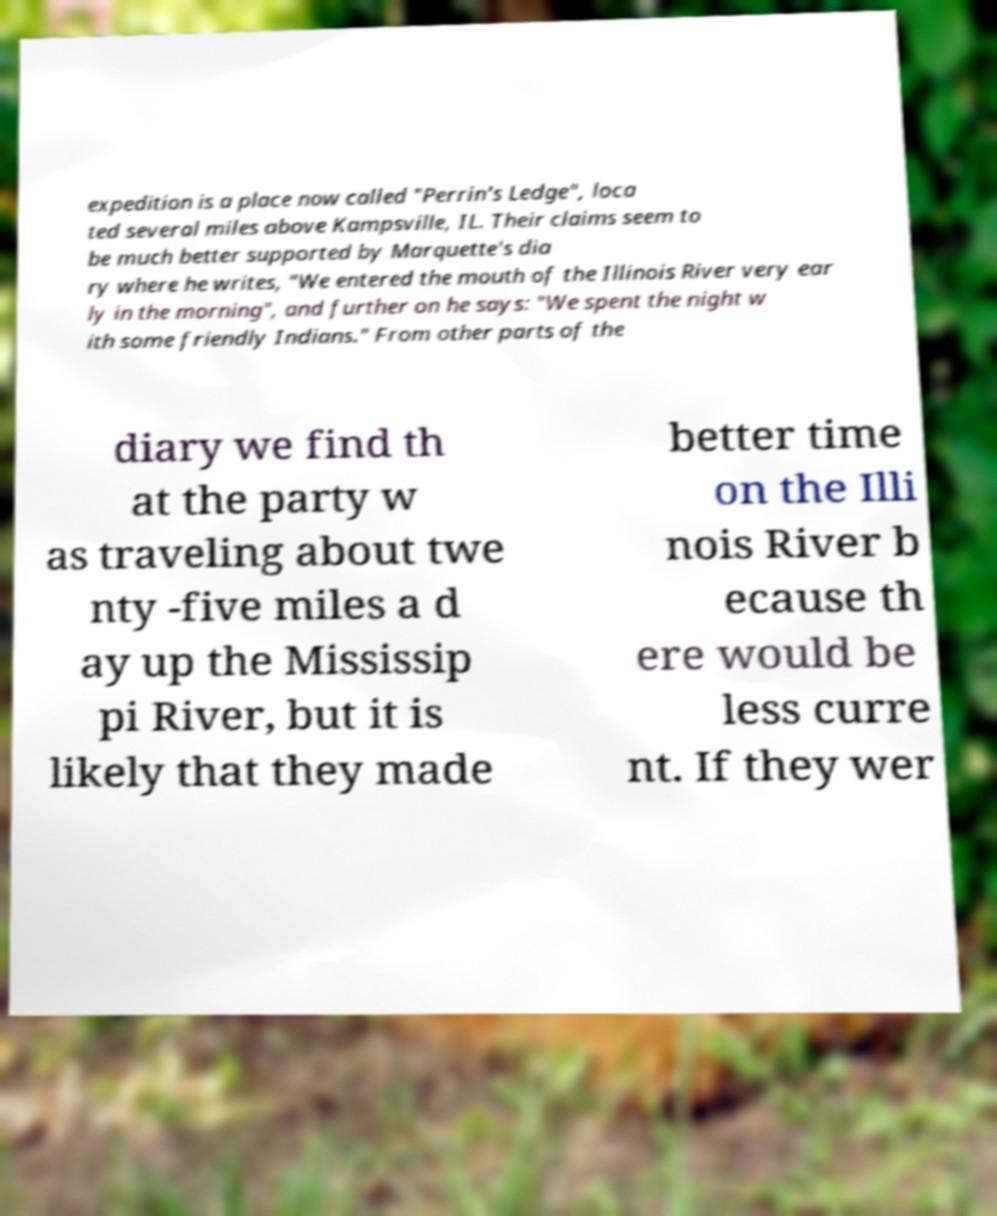There's text embedded in this image that I need extracted. Can you transcribe it verbatim? expedition is a place now called "Perrin's Ledge", loca ted several miles above Kampsville, IL. Their claims seem to be much better supported by Marquette's dia ry where he writes, "We entered the mouth of the Illinois River very ear ly in the morning", and further on he says: "We spent the night w ith some friendly Indians." From other parts of the diary we find th at the party w as traveling about twe nty -five miles a d ay up the Mississip pi River, but it is likely that they made better time on the Illi nois River b ecause th ere would be less curre nt. If they wer 